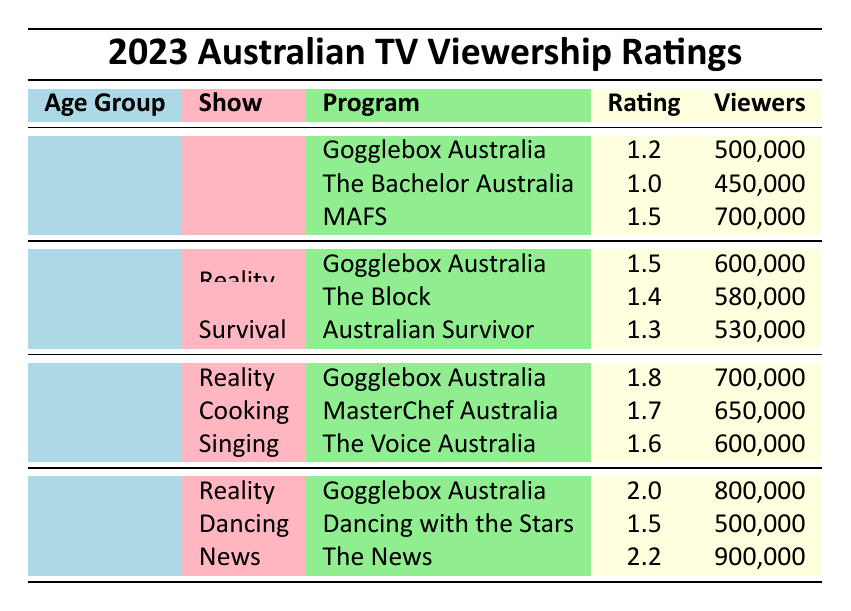What is the viewership count for Gogglebox Australia in the 50+ age group? The table indicates that in the 50+ age group, Gogglebox Australia had a viewership count of 800,000. This is directly referenced under the corresponding section for the show in that age group.
Answer: 800,000 Which show had the highest rating among 35-49 year-olds, and what was the rating? In the 35-49 age group, Gogglebox Australia had the highest rating of 1.8. This is determined by comparing the ratings of all three shows listed for this demographic.
Answer: Gogglebox Australia, 1.8 What is the average rating of Gogglebox Australia across all age groups? The ratings for Gogglebox Australia across the age groups are 1.2, 1.5, 1.8, and 2.0. To find the average, we sum these ratings (1.2 + 1.5 + 1.8 + 2.0 = 6.5) and divide by the number of groups (4). Thus, the average rating is 6.5 / 4 = 1.625.
Answer: 1.625 Does the show Dancing with the Stars have a rating lower than 1.5 in the 50+ age group? The rating for Dancing with the Stars in the 50+ age group is 1.5, meaning it is not lower than 1.5. This is determined by simply checking the rating value provided for this show in the respective age category.
Answer: No What is the total number of viewers for all shows in the 25-34 age group? To find the total viewers for the 25-34 age group, we add the viewers for each show: Gogglebox Australia (600,000) + The Block (580,000) + Australian Survivor (530,000) = 1,710,000.
Answer: 1,710,000 Which age group has the highest number of viewers watching MasterChef Australia? The table shows that MasterChef Australia is only listed under the 35-49 age group with a viewer count of 650,000. Since it does not appear in any other age group, this age group is the only one that can have viewers for this show.
Answer: 35-49 age group Is it true that the show The News had more viewers than Gogglebox Australia in the 50+ age group? The News had 900,000 viewers while Gogglebox Australia had 800,000 viewers in the 50+ age group. Since 900,000 is greater than 800,000, the statement is true.
Answer: Yes How many viewers did MAFS have compared to the total viewers of all shows in the 18-24 age group? MAFS had 700,000 viewers. The total for the 18-24 age group is calculated by adding the viewers for Gogglebox Australia (500,000), The Bachelor Australia (450,000), and MAFS (700,000), which totals 1,650,000. MAFS (700,000) is less than the total (1,650,000) thus confirming the comparison.
Answer: 700,000, which is less than 1,650,000 